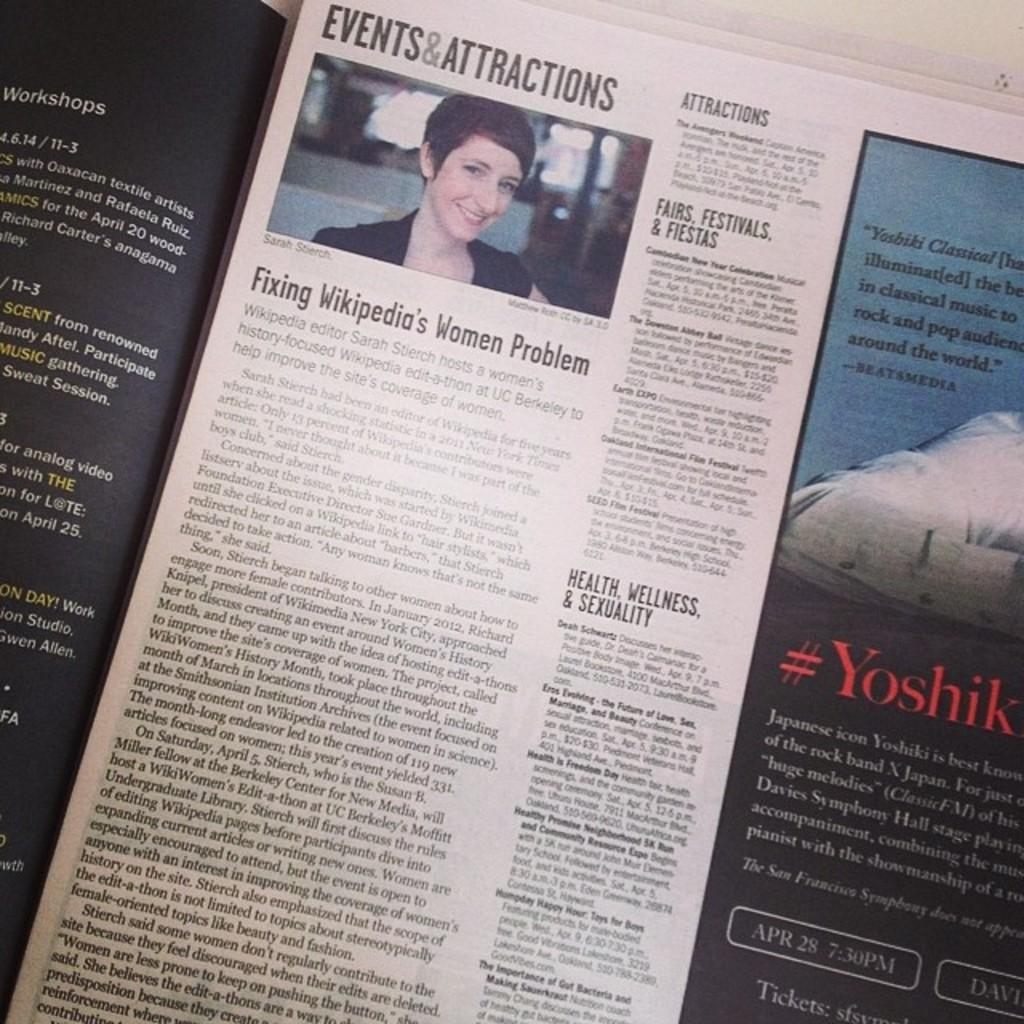What is the main object in the image? There is a newspaper in the image. What can be seen in the newspaper? There is an image of a lady in the newspaper. What else is visible in the image besides the newspaper? There is text visible in the image. Can you tell me the price of the creature swimming in the lake in the image? There is no creature or lake present in the image; it features a newspaper with an image of a lady and text. 